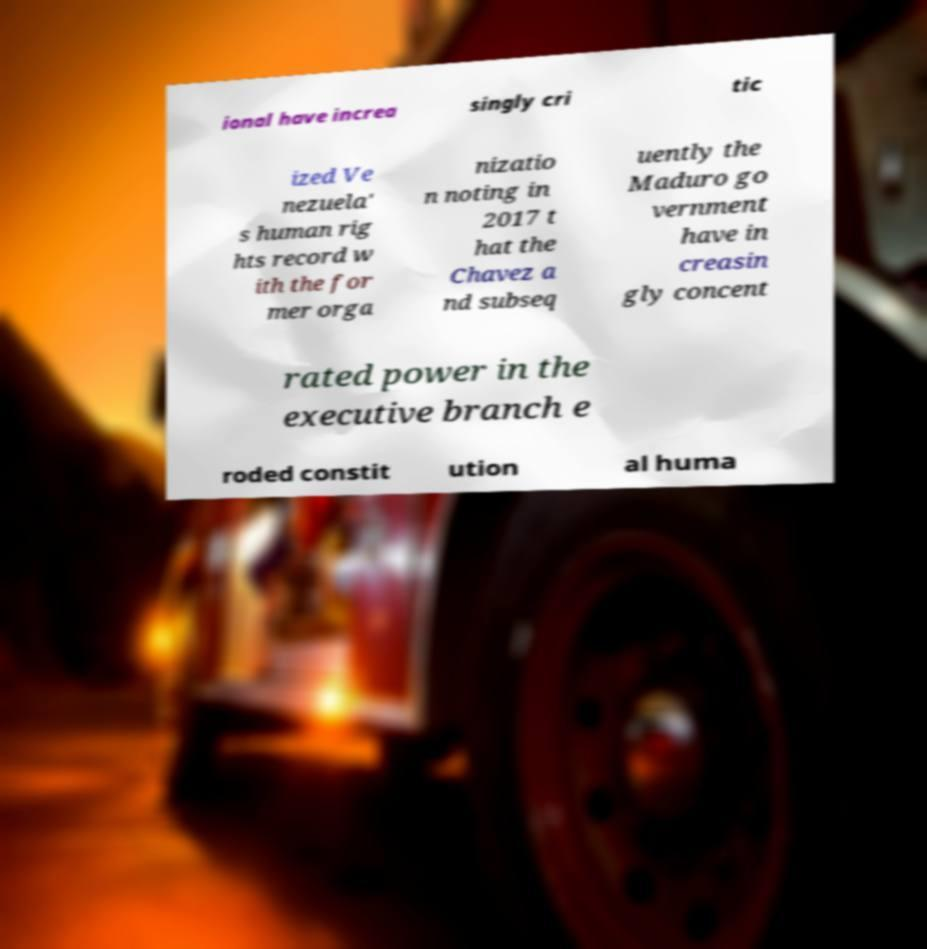Please identify and transcribe the text found in this image. ional have increa singly cri tic ized Ve nezuela' s human rig hts record w ith the for mer orga nizatio n noting in 2017 t hat the Chavez a nd subseq uently the Maduro go vernment have in creasin gly concent rated power in the executive branch e roded constit ution al huma 